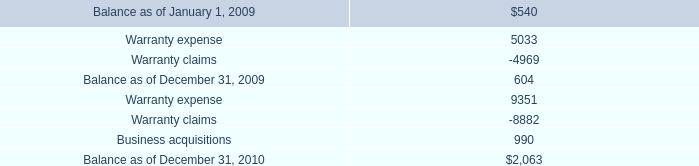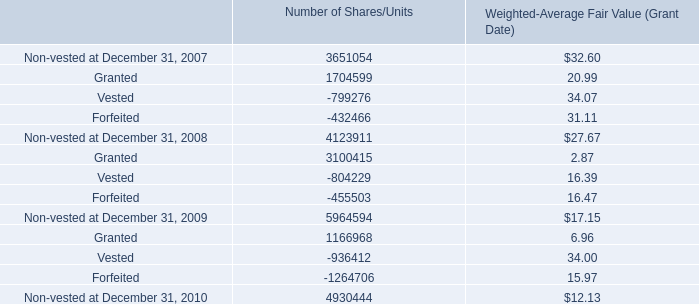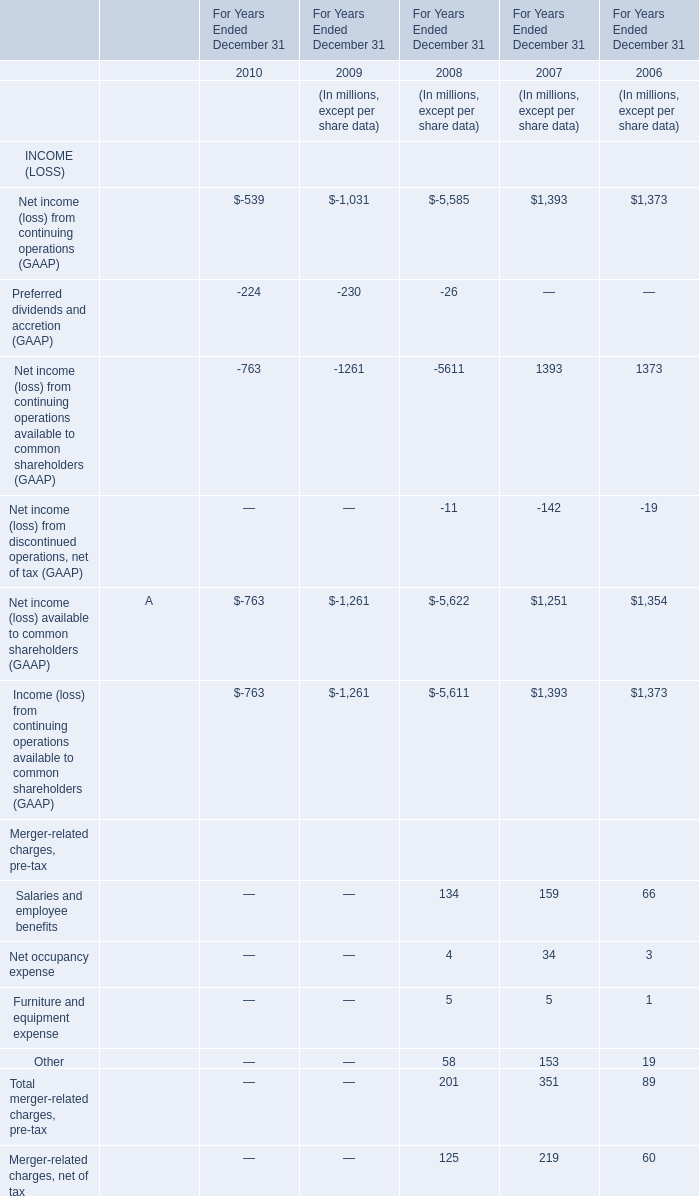What's the sum of Balance as of December 31, 2010, and Forfeited of Number of Shares/Units ? 
Computations: (2063.0 + 1264706.0)
Answer: 1266769.0. 